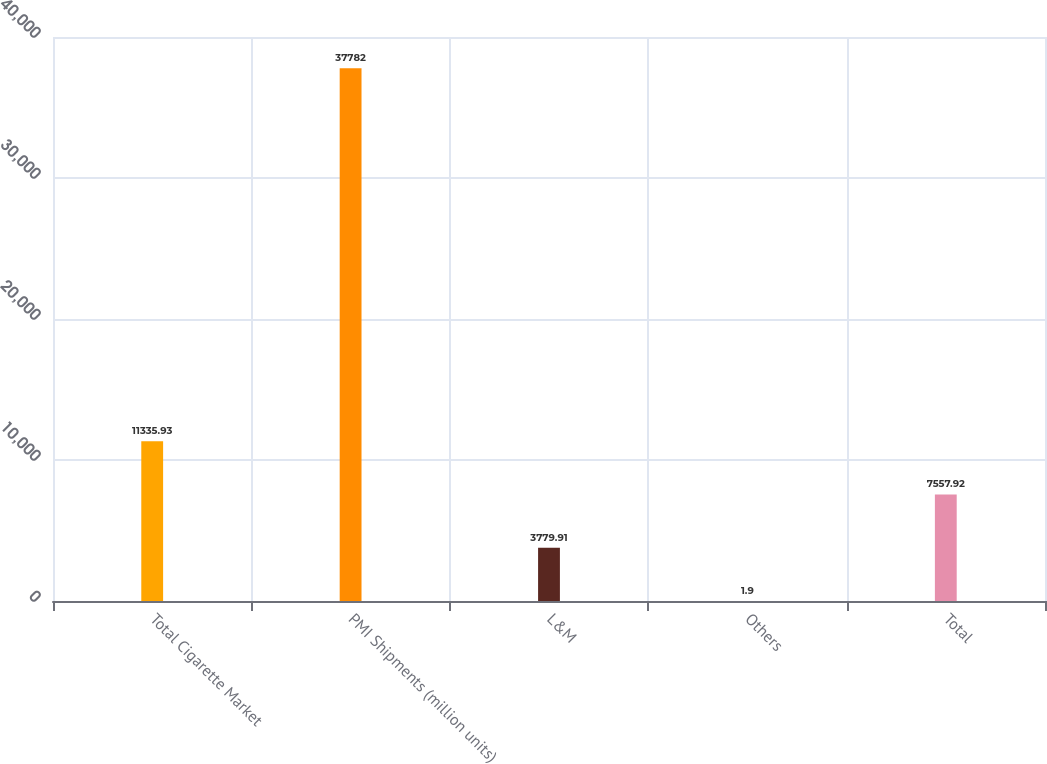<chart> <loc_0><loc_0><loc_500><loc_500><bar_chart><fcel>Total Cigarette Market<fcel>PMI Shipments (million units)<fcel>L&M<fcel>Others<fcel>Total<nl><fcel>11335.9<fcel>37782<fcel>3779.91<fcel>1.9<fcel>7557.92<nl></chart> 